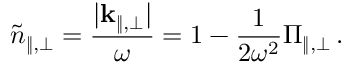<formula> <loc_0><loc_0><loc_500><loc_500>\tilde { n } _ { \| , \bot } = \frac { | { k } _ { \| , \bot } | } { \omega } = 1 - \frac { 1 } { 2 \omega ^ { 2 } } \Pi _ { \| , \bot } \, .</formula> 